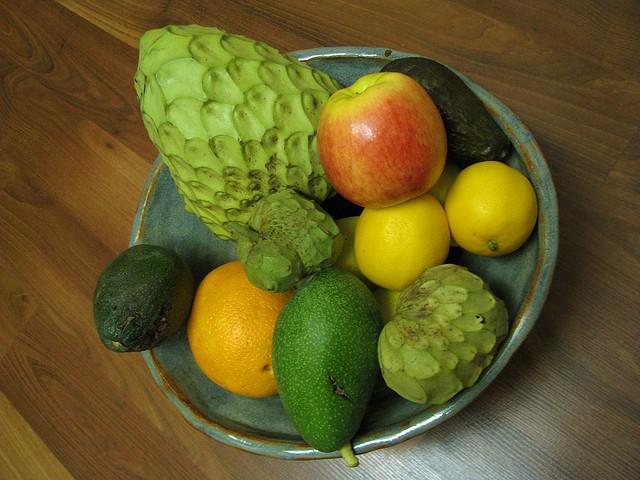What kind of fruits on the platter are yellow?
Answer briefly. Lemon. Is this produce fruit or vegetable?
Concise answer only. Fruit. How many bowls are there?
Be succinct. 1. Can you use some of these items to make guacamole?
Write a very short answer. Yes. 